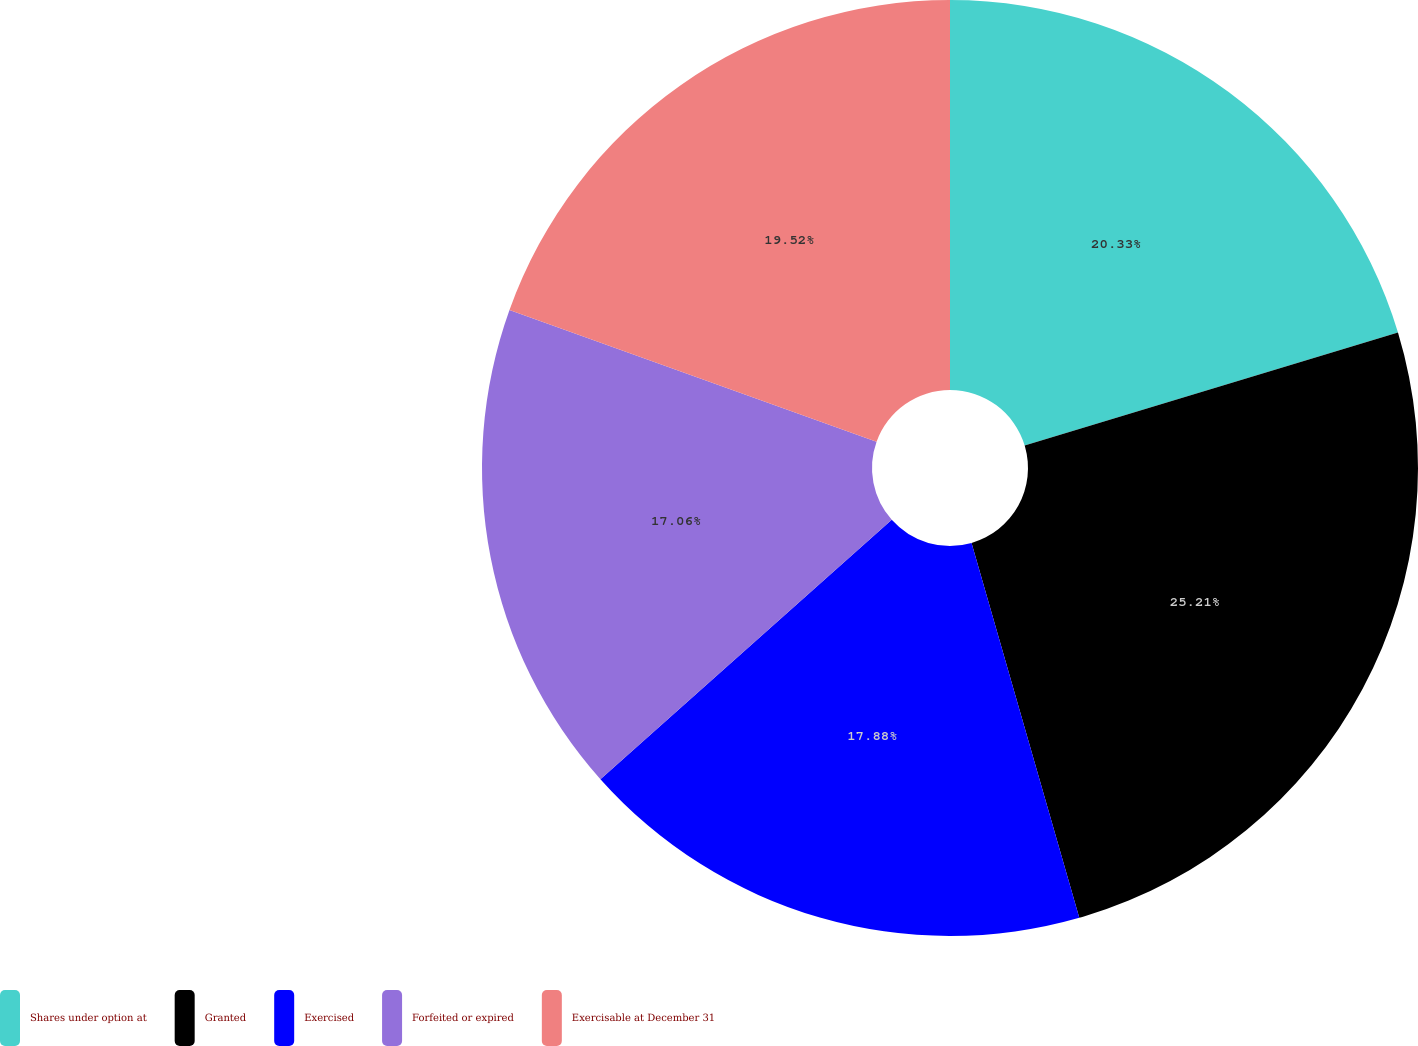Convert chart to OTSL. <chart><loc_0><loc_0><loc_500><loc_500><pie_chart><fcel>Shares under option at<fcel>Granted<fcel>Exercised<fcel>Forfeited or expired<fcel>Exercisable at December 31<nl><fcel>20.33%<fcel>25.22%<fcel>17.88%<fcel>17.06%<fcel>19.52%<nl></chart> 